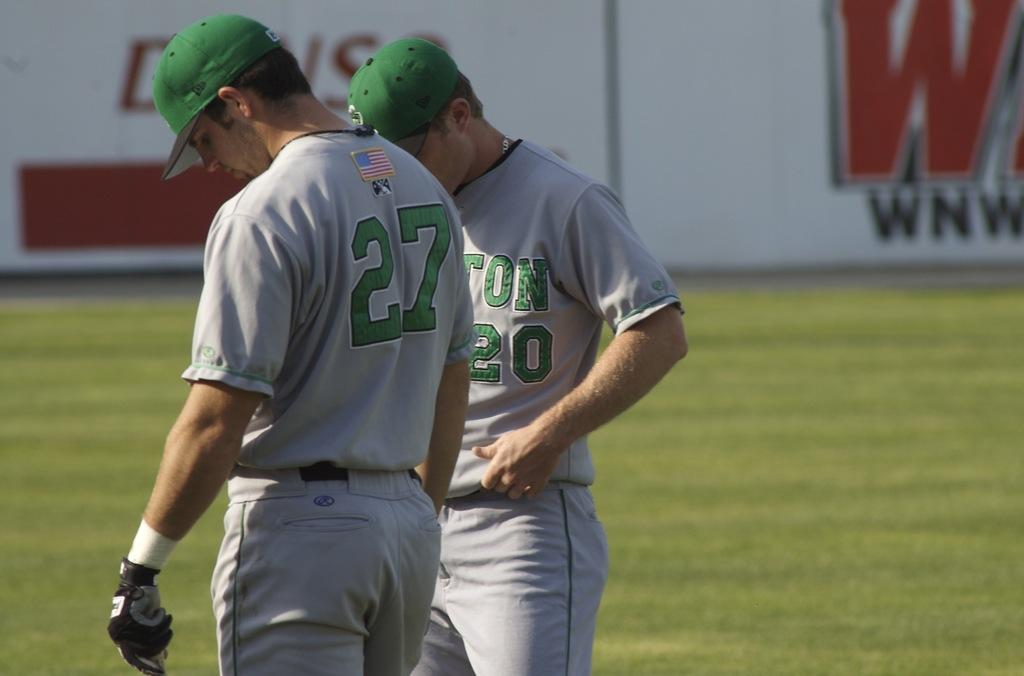How many people are in the image? There are two persons in the image. What are the persons wearing? The persons are wearing grey and green jerseys. Where are the persons standing? The persons are standing on the ground. What can be seen in the background of the image? There are boards in the background of the image. What colors are the boards? The boards are white, red, and black in color. What type of hat is the actor wearing in the image? There is no actor or hat present in the image. How much money can be seen in the image? There is no money visible in the image. 